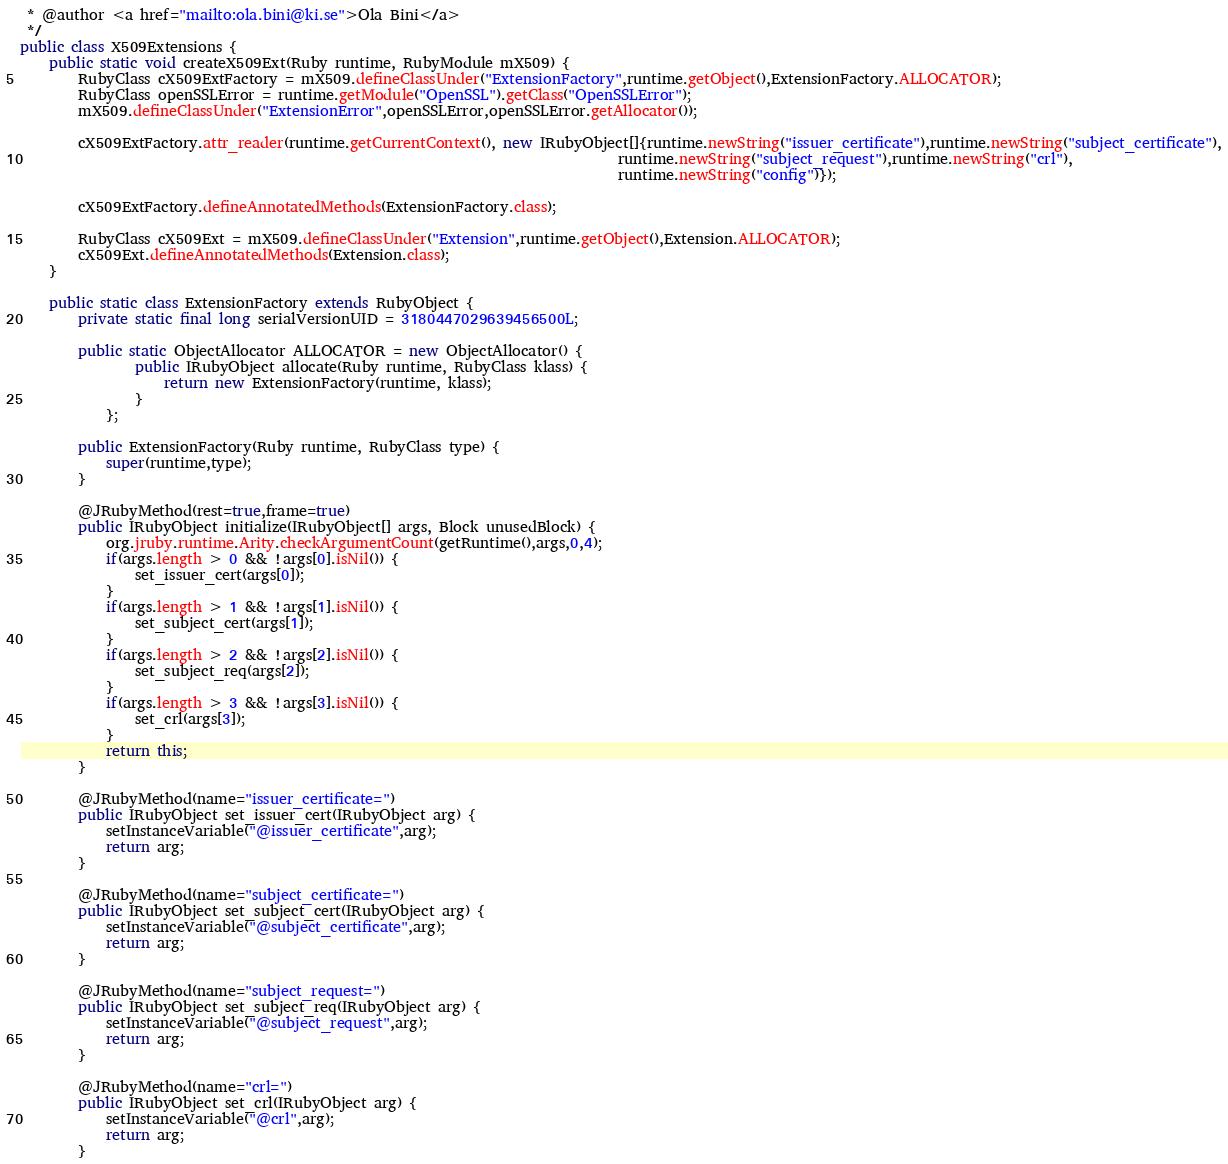Convert code to text. <code><loc_0><loc_0><loc_500><loc_500><_Java_> * @author <a href="mailto:ola.bini@ki.se">Ola Bini</a>
 */
public class X509Extensions {
    public static void createX509Ext(Ruby runtime, RubyModule mX509) {
        RubyClass cX509ExtFactory = mX509.defineClassUnder("ExtensionFactory",runtime.getObject(),ExtensionFactory.ALLOCATOR);
        RubyClass openSSLError = runtime.getModule("OpenSSL").getClass("OpenSSLError");
        mX509.defineClassUnder("ExtensionError",openSSLError,openSSLError.getAllocator());
        
        cX509ExtFactory.attr_reader(runtime.getCurrentContext(), new IRubyObject[]{runtime.newString("issuer_certificate"),runtime.newString("subject_certificate"),
                                                                                   runtime.newString("subject_request"),runtime.newString("crl"),
                                                                                   runtime.newString("config")});

        cX509ExtFactory.defineAnnotatedMethods(ExtensionFactory.class);

        RubyClass cX509Ext = mX509.defineClassUnder("Extension",runtime.getObject(),Extension.ALLOCATOR);
        cX509Ext.defineAnnotatedMethods(Extension.class);
    }

    public static class ExtensionFactory extends RubyObject {
        private static final long serialVersionUID = 3180447029639456500L;

        public static ObjectAllocator ALLOCATOR = new ObjectAllocator() {
                public IRubyObject allocate(Ruby runtime, RubyClass klass) {
                    return new ExtensionFactory(runtime, klass);
                }
            };

        public ExtensionFactory(Ruby runtime, RubyClass type) {
            super(runtime,type);
        }

        @JRubyMethod(rest=true,frame=true)
        public IRubyObject initialize(IRubyObject[] args, Block unusedBlock) {
            org.jruby.runtime.Arity.checkArgumentCount(getRuntime(),args,0,4);
            if(args.length > 0 && !args[0].isNil()) {
                set_issuer_cert(args[0]);
            }
            if(args.length > 1 && !args[1].isNil()) {
                set_subject_cert(args[1]);
            }
            if(args.length > 2 && !args[2].isNil()) {
                set_subject_req(args[2]);
            }
            if(args.length > 3 && !args[3].isNil()) {
                set_crl(args[3]);
            }
            return this;
        }

        @JRubyMethod(name="issuer_certificate=")
        public IRubyObject set_issuer_cert(IRubyObject arg) {
            setInstanceVariable("@issuer_certificate",arg);
            return arg;
        }

        @JRubyMethod(name="subject_certificate=")
        public IRubyObject set_subject_cert(IRubyObject arg) {
            setInstanceVariable("@subject_certificate",arg);
            return arg;
        }

        @JRubyMethod(name="subject_request=")
        public IRubyObject set_subject_req(IRubyObject arg) {
            setInstanceVariable("@subject_request",arg);
            return arg;
        }

        @JRubyMethod(name="crl=")
        public IRubyObject set_crl(IRubyObject arg) {
            setInstanceVariable("@crl",arg);
            return arg;
        }
</code> 